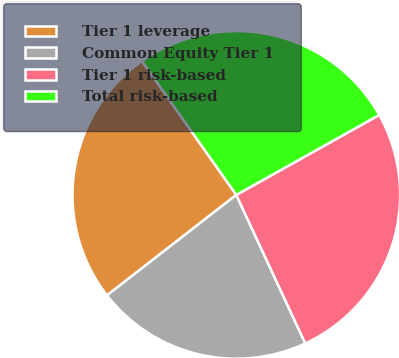Convert chart to OTSL. <chart><loc_0><loc_0><loc_500><loc_500><pie_chart><fcel>Tier 1 leverage<fcel>Common Equity Tier 1<fcel>Tier 1 risk-based<fcel>Total risk-based<nl><fcel>25.74%<fcel>21.41%<fcel>26.2%<fcel>26.66%<nl></chart> 